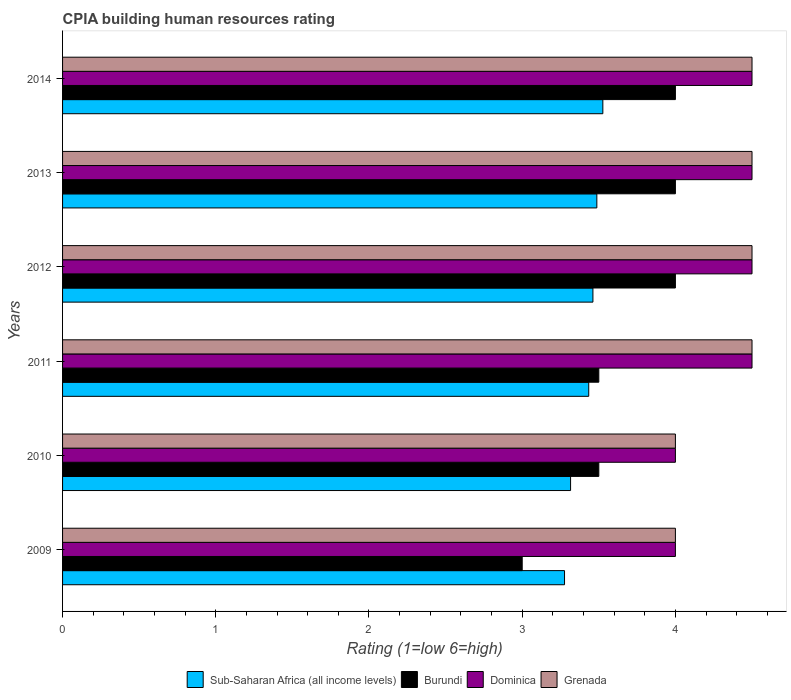How many different coloured bars are there?
Keep it short and to the point. 4. How many groups of bars are there?
Provide a short and direct response. 6. Are the number of bars on each tick of the Y-axis equal?
Give a very brief answer. Yes. How many bars are there on the 1st tick from the top?
Your answer should be compact. 4. How many bars are there on the 6th tick from the bottom?
Your answer should be very brief. 4. Across all years, what is the maximum CPIA rating in Sub-Saharan Africa (all income levels)?
Provide a succinct answer. 3.53. What is the total CPIA rating in Sub-Saharan Africa (all income levels) in the graph?
Offer a very short reply. 20.5. What is the difference between the CPIA rating in Sub-Saharan Africa (all income levels) in 2010 and that in 2013?
Provide a succinct answer. -0.17. What is the difference between the CPIA rating in Sub-Saharan Africa (all income levels) in 2010 and the CPIA rating in Dominica in 2011?
Ensure brevity in your answer.  -1.18. What is the average CPIA rating in Dominica per year?
Provide a short and direct response. 4.33. In the year 2012, what is the difference between the CPIA rating in Dominica and CPIA rating in Sub-Saharan Africa (all income levels)?
Give a very brief answer. 1.04. What is the ratio of the CPIA rating in Dominica in 2009 to that in 2010?
Offer a terse response. 1. Is the CPIA rating in Burundi in 2011 less than that in 2013?
Your answer should be compact. Yes. What is the difference between the highest and the second highest CPIA rating in Sub-Saharan Africa (all income levels)?
Provide a succinct answer. 0.04. What is the difference between the highest and the lowest CPIA rating in Sub-Saharan Africa (all income levels)?
Ensure brevity in your answer.  0.25. In how many years, is the CPIA rating in Sub-Saharan Africa (all income levels) greater than the average CPIA rating in Sub-Saharan Africa (all income levels) taken over all years?
Offer a terse response. 4. What does the 4th bar from the top in 2012 represents?
Make the answer very short. Sub-Saharan Africa (all income levels). What does the 4th bar from the bottom in 2010 represents?
Provide a short and direct response. Grenada. Is it the case that in every year, the sum of the CPIA rating in Burundi and CPIA rating in Sub-Saharan Africa (all income levels) is greater than the CPIA rating in Dominica?
Provide a short and direct response. Yes. Does the graph contain grids?
Provide a succinct answer. No. Where does the legend appear in the graph?
Offer a very short reply. Bottom center. How many legend labels are there?
Your response must be concise. 4. What is the title of the graph?
Your answer should be very brief. CPIA building human resources rating. What is the label or title of the Y-axis?
Your response must be concise. Years. What is the Rating (1=low 6=high) in Sub-Saharan Africa (all income levels) in 2009?
Provide a short and direct response. 3.28. What is the Rating (1=low 6=high) of Burundi in 2009?
Ensure brevity in your answer.  3. What is the Rating (1=low 6=high) of Sub-Saharan Africa (all income levels) in 2010?
Provide a succinct answer. 3.32. What is the Rating (1=low 6=high) of Burundi in 2010?
Your answer should be very brief. 3.5. What is the Rating (1=low 6=high) of Sub-Saharan Africa (all income levels) in 2011?
Ensure brevity in your answer.  3.43. What is the Rating (1=low 6=high) in Burundi in 2011?
Your answer should be compact. 3.5. What is the Rating (1=low 6=high) in Dominica in 2011?
Offer a very short reply. 4.5. What is the Rating (1=low 6=high) of Grenada in 2011?
Your response must be concise. 4.5. What is the Rating (1=low 6=high) in Sub-Saharan Africa (all income levels) in 2012?
Your response must be concise. 3.46. What is the Rating (1=low 6=high) of Sub-Saharan Africa (all income levels) in 2013?
Provide a succinct answer. 3.49. What is the Rating (1=low 6=high) of Burundi in 2013?
Make the answer very short. 4. What is the Rating (1=low 6=high) in Grenada in 2013?
Provide a succinct answer. 4.5. What is the Rating (1=low 6=high) in Sub-Saharan Africa (all income levels) in 2014?
Make the answer very short. 3.53. What is the Rating (1=low 6=high) of Dominica in 2014?
Offer a very short reply. 4.5. Across all years, what is the maximum Rating (1=low 6=high) of Sub-Saharan Africa (all income levels)?
Your response must be concise. 3.53. Across all years, what is the maximum Rating (1=low 6=high) of Burundi?
Ensure brevity in your answer.  4. Across all years, what is the maximum Rating (1=low 6=high) of Dominica?
Give a very brief answer. 4.5. Across all years, what is the minimum Rating (1=low 6=high) of Sub-Saharan Africa (all income levels)?
Offer a very short reply. 3.28. What is the total Rating (1=low 6=high) in Sub-Saharan Africa (all income levels) in the graph?
Provide a short and direct response. 20.5. What is the total Rating (1=low 6=high) of Dominica in the graph?
Your response must be concise. 26. What is the difference between the Rating (1=low 6=high) of Sub-Saharan Africa (all income levels) in 2009 and that in 2010?
Offer a very short reply. -0.04. What is the difference between the Rating (1=low 6=high) in Burundi in 2009 and that in 2010?
Provide a short and direct response. -0.5. What is the difference between the Rating (1=low 6=high) in Dominica in 2009 and that in 2010?
Give a very brief answer. 0. What is the difference between the Rating (1=low 6=high) of Grenada in 2009 and that in 2010?
Provide a succinct answer. 0. What is the difference between the Rating (1=low 6=high) of Sub-Saharan Africa (all income levels) in 2009 and that in 2011?
Ensure brevity in your answer.  -0.16. What is the difference between the Rating (1=low 6=high) of Burundi in 2009 and that in 2011?
Offer a terse response. -0.5. What is the difference between the Rating (1=low 6=high) of Dominica in 2009 and that in 2011?
Keep it short and to the point. -0.5. What is the difference between the Rating (1=low 6=high) in Sub-Saharan Africa (all income levels) in 2009 and that in 2012?
Your response must be concise. -0.19. What is the difference between the Rating (1=low 6=high) of Burundi in 2009 and that in 2012?
Keep it short and to the point. -1. What is the difference between the Rating (1=low 6=high) in Dominica in 2009 and that in 2012?
Your response must be concise. -0.5. What is the difference between the Rating (1=low 6=high) in Sub-Saharan Africa (all income levels) in 2009 and that in 2013?
Your response must be concise. -0.21. What is the difference between the Rating (1=low 6=high) of Burundi in 2009 and that in 2013?
Keep it short and to the point. -1. What is the difference between the Rating (1=low 6=high) in Dominica in 2009 and that in 2013?
Make the answer very short. -0.5. What is the difference between the Rating (1=low 6=high) in Sub-Saharan Africa (all income levels) in 2009 and that in 2014?
Your answer should be compact. -0.25. What is the difference between the Rating (1=low 6=high) in Grenada in 2009 and that in 2014?
Your answer should be compact. -0.5. What is the difference between the Rating (1=low 6=high) of Sub-Saharan Africa (all income levels) in 2010 and that in 2011?
Provide a short and direct response. -0.12. What is the difference between the Rating (1=low 6=high) in Burundi in 2010 and that in 2011?
Your answer should be compact. 0. What is the difference between the Rating (1=low 6=high) of Grenada in 2010 and that in 2011?
Give a very brief answer. -0.5. What is the difference between the Rating (1=low 6=high) in Sub-Saharan Africa (all income levels) in 2010 and that in 2012?
Provide a short and direct response. -0.15. What is the difference between the Rating (1=low 6=high) of Burundi in 2010 and that in 2012?
Your answer should be compact. -0.5. What is the difference between the Rating (1=low 6=high) of Sub-Saharan Africa (all income levels) in 2010 and that in 2013?
Keep it short and to the point. -0.17. What is the difference between the Rating (1=low 6=high) of Dominica in 2010 and that in 2013?
Your response must be concise. -0.5. What is the difference between the Rating (1=low 6=high) of Grenada in 2010 and that in 2013?
Offer a terse response. -0.5. What is the difference between the Rating (1=low 6=high) of Sub-Saharan Africa (all income levels) in 2010 and that in 2014?
Your answer should be compact. -0.21. What is the difference between the Rating (1=low 6=high) of Dominica in 2010 and that in 2014?
Provide a succinct answer. -0.5. What is the difference between the Rating (1=low 6=high) of Grenada in 2010 and that in 2014?
Give a very brief answer. -0.5. What is the difference between the Rating (1=low 6=high) of Sub-Saharan Africa (all income levels) in 2011 and that in 2012?
Your answer should be very brief. -0.03. What is the difference between the Rating (1=low 6=high) in Dominica in 2011 and that in 2012?
Make the answer very short. 0. What is the difference between the Rating (1=low 6=high) of Grenada in 2011 and that in 2012?
Provide a short and direct response. 0. What is the difference between the Rating (1=low 6=high) of Sub-Saharan Africa (all income levels) in 2011 and that in 2013?
Offer a terse response. -0.05. What is the difference between the Rating (1=low 6=high) of Sub-Saharan Africa (all income levels) in 2011 and that in 2014?
Keep it short and to the point. -0.09. What is the difference between the Rating (1=low 6=high) in Burundi in 2011 and that in 2014?
Make the answer very short. -0.5. What is the difference between the Rating (1=low 6=high) in Dominica in 2011 and that in 2014?
Give a very brief answer. 0. What is the difference between the Rating (1=low 6=high) of Grenada in 2011 and that in 2014?
Your response must be concise. 0. What is the difference between the Rating (1=low 6=high) of Sub-Saharan Africa (all income levels) in 2012 and that in 2013?
Give a very brief answer. -0.03. What is the difference between the Rating (1=low 6=high) of Dominica in 2012 and that in 2013?
Offer a terse response. 0. What is the difference between the Rating (1=low 6=high) in Sub-Saharan Africa (all income levels) in 2012 and that in 2014?
Your answer should be compact. -0.06. What is the difference between the Rating (1=low 6=high) of Burundi in 2012 and that in 2014?
Your answer should be compact. 0. What is the difference between the Rating (1=low 6=high) of Dominica in 2012 and that in 2014?
Offer a very short reply. 0. What is the difference between the Rating (1=low 6=high) in Grenada in 2012 and that in 2014?
Offer a very short reply. 0. What is the difference between the Rating (1=low 6=high) of Sub-Saharan Africa (all income levels) in 2013 and that in 2014?
Provide a short and direct response. -0.04. What is the difference between the Rating (1=low 6=high) in Grenada in 2013 and that in 2014?
Provide a succinct answer. 0. What is the difference between the Rating (1=low 6=high) of Sub-Saharan Africa (all income levels) in 2009 and the Rating (1=low 6=high) of Burundi in 2010?
Ensure brevity in your answer.  -0.22. What is the difference between the Rating (1=low 6=high) of Sub-Saharan Africa (all income levels) in 2009 and the Rating (1=low 6=high) of Dominica in 2010?
Provide a succinct answer. -0.72. What is the difference between the Rating (1=low 6=high) in Sub-Saharan Africa (all income levels) in 2009 and the Rating (1=low 6=high) in Grenada in 2010?
Offer a terse response. -0.72. What is the difference between the Rating (1=low 6=high) in Burundi in 2009 and the Rating (1=low 6=high) in Dominica in 2010?
Offer a terse response. -1. What is the difference between the Rating (1=low 6=high) in Burundi in 2009 and the Rating (1=low 6=high) in Grenada in 2010?
Your answer should be very brief. -1. What is the difference between the Rating (1=low 6=high) in Sub-Saharan Africa (all income levels) in 2009 and the Rating (1=low 6=high) in Burundi in 2011?
Your answer should be very brief. -0.22. What is the difference between the Rating (1=low 6=high) of Sub-Saharan Africa (all income levels) in 2009 and the Rating (1=low 6=high) of Dominica in 2011?
Provide a short and direct response. -1.22. What is the difference between the Rating (1=low 6=high) of Sub-Saharan Africa (all income levels) in 2009 and the Rating (1=low 6=high) of Grenada in 2011?
Ensure brevity in your answer.  -1.22. What is the difference between the Rating (1=low 6=high) in Burundi in 2009 and the Rating (1=low 6=high) in Dominica in 2011?
Your answer should be compact. -1.5. What is the difference between the Rating (1=low 6=high) in Dominica in 2009 and the Rating (1=low 6=high) in Grenada in 2011?
Keep it short and to the point. -0.5. What is the difference between the Rating (1=low 6=high) of Sub-Saharan Africa (all income levels) in 2009 and the Rating (1=low 6=high) of Burundi in 2012?
Your answer should be very brief. -0.72. What is the difference between the Rating (1=low 6=high) of Sub-Saharan Africa (all income levels) in 2009 and the Rating (1=low 6=high) of Dominica in 2012?
Your response must be concise. -1.22. What is the difference between the Rating (1=low 6=high) of Sub-Saharan Africa (all income levels) in 2009 and the Rating (1=low 6=high) of Grenada in 2012?
Keep it short and to the point. -1.22. What is the difference between the Rating (1=low 6=high) of Burundi in 2009 and the Rating (1=low 6=high) of Dominica in 2012?
Ensure brevity in your answer.  -1.5. What is the difference between the Rating (1=low 6=high) of Sub-Saharan Africa (all income levels) in 2009 and the Rating (1=low 6=high) of Burundi in 2013?
Offer a terse response. -0.72. What is the difference between the Rating (1=low 6=high) of Sub-Saharan Africa (all income levels) in 2009 and the Rating (1=low 6=high) of Dominica in 2013?
Offer a terse response. -1.22. What is the difference between the Rating (1=low 6=high) in Sub-Saharan Africa (all income levels) in 2009 and the Rating (1=low 6=high) in Grenada in 2013?
Offer a terse response. -1.22. What is the difference between the Rating (1=low 6=high) in Burundi in 2009 and the Rating (1=low 6=high) in Grenada in 2013?
Offer a very short reply. -1.5. What is the difference between the Rating (1=low 6=high) in Dominica in 2009 and the Rating (1=low 6=high) in Grenada in 2013?
Your response must be concise. -0.5. What is the difference between the Rating (1=low 6=high) in Sub-Saharan Africa (all income levels) in 2009 and the Rating (1=low 6=high) in Burundi in 2014?
Your answer should be very brief. -0.72. What is the difference between the Rating (1=low 6=high) of Sub-Saharan Africa (all income levels) in 2009 and the Rating (1=low 6=high) of Dominica in 2014?
Provide a succinct answer. -1.22. What is the difference between the Rating (1=low 6=high) in Sub-Saharan Africa (all income levels) in 2009 and the Rating (1=low 6=high) in Grenada in 2014?
Offer a very short reply. -1.22. What is the difference between the Rating (1=low 6=high) of Burundi in 2009 and the Rating (1=low 6=high) of Grenada in 2014?
Offer a very short reply. -1.5. What is the difference between the Rating (1=low 6=high) in Sub-Saharan Africa (all income levels) in 2010 and the Rating (1=low 6=high) in Burundi in 2011?
Ensure brevity in your answer.  -0.18. What is the difference between the Rating (1=low 6=high) in Sub-Saharan Africa (all income levels) in 2010 and the Rating (1=low 6=high) in Dominica in 2011?
Ensure brevity in your answer.  -1.18. What is the difference between the Rating (1=low 6=high) in Sub-Saharan Africa (all income levels) in 2010 and the Rating (1=low 6=high) in Grenada in 2011?
Provide a succinct answer. -1.18. What is the difference between the Rating (1=low 6=high) in Sub-Saharan Africa (all income levels) in 2010 and the Rating (1=low 6=high) in Burundi in 2012?
Ensure brevity in your answer.  -0.68. What is the difference between the Rating (1=low 6=high) in Sub-Saharan Africa (all income levels) in 2010 and the Rating (1=low 6=high) in Dominica in 2012?
Your answer should be very brief. -1.18. What is the difference between the Rating (1=low 6=high) of Sub-Saharan Africa (all income levels) in 2010 and the Rating (1=low 6=high) of Grenada in 2012?
Keep it short and to the point. -1.18. What is the difference between the Rating (1=low 6=high) in Dominica in 2010 and the Rating (1=low 6=high) in Grenada in 2012?
Provide a short and direct response. -0.5. What is the difference between the Rating (1=low 6=high) in Sub-Saharan Africa (all income levels) in 2010 and the Rating (1=low 6=high) in Burundi in 2013?
Offer a very short reply. -0.68. What is the difference between the Rating (1=low 6=high) of Sub-Saharan Africa (all income levels) in 2010 and the Rating (1=low 6=high) of Dominica in 2013?
Keep it short and to the point. -1.18. What is the difference between the Rating (1=low 6=high) in Sub-Saharan Africa (all income levels) in 2010 and the Rating (1=low 6=high) in Grenada in 2013?
Make the answer very short. -1.18. What is the difference between the Rating (1=low 6=high) in Burundi in 2010 and the Rating (1=low 6=high) in Dominica in 2013?
Ensure brevity in your answer.  -1. What is the difference between the Rating (1=low 6=high) of Burundi in 2010 and the Rating (1=low 6=high) of Grenada in 2013?
Keep it short and to the point. -1. What is the difference between the Rating (1=low 6=high) in Dominica in 2010 and the Rating (1=low 6=high) in Grenada in 2013?
Keep it short and to the point. -0.5. What is the difference between the Rating (1=low 6=high) of Sub-Saharan Africa (all income levels) in 2010 and the Rating (1=low 6=high) of Burundi in 2014?
Provide a succinct answer. -0.68. What is the difference between the Rating (1=low 6=high) of Sub-Saharan Africa (all income levels) in 2010 and the Rating (1=low 6=high) of Dominica in 2014?
Provide a short and direct response. -1.18. What is the difference between the Rating (1=low 6=high) of Sub-Saharan Africa (all income levels) in 2010 and the Rating (1=low 6=high) of Grenada in 2014?
Give a very brief answer. -1.18. What is the difference between the Rating (1=low 6=high) of Burundi in 2010 and the Rating (1=low 6=high) of Dominica in 2014?
Offer a terse response. -1. What is the difference between the Rating (1=low 6=high) in Dominica in 2010 and the Rating (1=low 6=high) in Grenada in 2014?
Make the answer very short. -0.5. What is the difference between the Rating (1=low 6=high) in Sub-Saharan Africa (all income levels) in 2011 and the Rating (1=low 6=high) in Burundi in 2012?
Offer a terse response. -0.57. What is the difference between the Rating (1=low 6=high) in Sub-Saharan Africa (all income levels) in 2011 and the Rating (1=low 6=high) in Dominica in 2012?
Ensure brevity in your answer.  -1.07. What is the difference between the Rating (1=low 6=high) of Sub-Saharan Africa (all income levels) in 2011 and the Rating (1=low 6=high) of Grenada in 2012?
Ensure brevity in your answer.  -1.07. What is the difference between the Rating (1=low 6=high) in Burundi in 2011 and the Rating (1=low 6=high) in Dominica in 2012?
Provide a succinct answer. -1. What is the difference between the Rating (1=low 6=high) in Burundi in 2011 and the Rating (1=low 6=high) in Grenada in 2012?
Your answer should be very brief. -1. What is the difference between the Rating (1=low 6=high) in Dominica in 2011 and the Rating (1=low 6=high) in Grenada in 2012?
Provide a short and direct response. 0. What is the difference between the Rating (1=low 6=high) in Sub-Saharan Africa (all income levels) in 2011 and the Rating (1=low 6=high) in Burundi in 2013?
Offer a very short reply. -0.57. What is the difference between the Rating (1=low 6=high) in Sub-Saharan Africa (all income levels) in 2011 and the Rating (1=low 6=high) in Dominica in 2013?
Provide a short and direct response. -1.07. What is the difference between the Rating (1=low 6=high) in Sub-Saharan Africa (all income levels) in 2011 and the Rating (1=low 6=high) in Grenada in 2013?
Provide a short and direct response. -1.07. What is the difference between the Rating (1=low 6=high) of Dominica in 2011 and the Rating (1=low 6=high) of Grenada in 2013?
Provide a short and direct response. 0. What is the difference between the Rating (1=low 6=high) of Sub-Saharan Africa (all income levels) in 2011 and the Rating (1=low 6=high) of Burundi in 2014?
Ensure brevity in your answer.  -0.57. What is the difference between the Rating (1=low 6=high) in Sub-Saharan Africa (all income levels) in 2011 and the Rating (1=low 6=high) in Dominica in 2014?
Your answer should be very brief. -1.07. What is the difference between the Rating (1=low 6=high) in Sub-Saharan Africa (all income levels) in 2011 and the Rating (1=low 6=high) in Grenada in 2014?
Your response must be concise. -1.07. What is the difference between the Rating (1=low 6=high) in Dominica in 2011 and the Rating (1=low 6=high) in Grenada in 2014?
Make the answer very short. 0. What is the difference between the Rating (1=low 6=high) in Sub-Saharan Africa (all income levels) in 2012 and the Rating (1=low 6=high) in Burundi in 2013?
Your answer should be very brief. -0.54. What is the difference between the Rating (1=low 6=high) in Sub-Saharan Africa (all income levels) in 2012 and the Rating (1=low 6=high) in Dominica in 2013?
Make the answer very short. -1.04. What is the difference between the Rating (1=low 6=high) in Sub-Saharan Africa (all income levels) in 2012 and the Rating (1=low 6=high) in Grenada in 2013?
Your response must be concise. -1.04. What is the difference between the Rating (1=low 6=high) of Burundi in 2012 and the Rating (1=low 6=high) of Grenada in 2013?
Make the answer very short. -0.5. What is the difference between the Rating (1=low 6=high) of Sub-Saharan Africa (all income levels) in 2012 and the Rating (1=low 6=high) of Burundi in 2014?
Provide a succinct answer. -0.54. What is the difference between the Rating (1=low 6=high) of Sub-Saharan Africa (all income levels) in 2012 and the Rating (1=low 6=high) of Dominica in 2014?
Make the answer very short. -1.04. What is the difference between the Rating (1=low 6=high) of Sub-Saharan Africa (all income levels) in 2012 and the Rating (1=low 6=high) of Grenada in 2014?
Offer a terse response. -1.04. What is the difference between the Rating (1=low 6=high) of Dominica in 2012 and the Rating (1=low 6=high) of Grenada in 2014?
Offer a terse response. 0. What is the difference between the Rating (1=low 6=high) of Sub-Saharan Africa (all income levels) in 2013 and the Rating (1=low 6=high) of Burundi in 2014?
Your response must be concise. -0.51. What is the difference between the Rating (1=low 6=high) of Sub-Saharan Africa (all income levels) in 2013 and the Rating (1=low 6=high) of Dominica in 2014?
Make the answer very short. -1.01. What is the difference between the Rating (1=low 6=high) in Sub-Saharan Africa (all income levels) in 2013 and the Rating (1=low 6=high) in Grenada in 2014?
Your response must be concise. -1.01. What is the difference between the Rating (1=low 6=high) of Dominica in 2013 and the Rating (1=low 6=high) of Grenada in 2014?
Keep it short and to the point. 0. What is the average Rating (1=low 6=high) of Sub-Saharan Africa (all income levels) per year?
Provide a succinct answer. 3.42. What is the average Rating (1=low 6=high) in Burundi per year?
Give a very brief answer. 3.67. What is the average Rating (1=low 6=high) of Dominica per year?
Make the answer very short. 4.33. What is the average Rating (1=low 6=high) in Grenada per year?
Give a very brief answer. 4.33. In the year 2009, what is the difference between the Rating (1=low 6=high) in Sub-Saharan Africa (all income levels) and Rating (1=low 6=high) in Burundi?
Keep it short and to the point. 0.28. In the year 2009, what is the difference between the Rating (1=low 6=high) in Sub-Saharan Africa (all income levels) and Rating (1=low 6=high) in Dominica?
Your answer should be compact. -0.72. In the year 2009, what is the difference between the Rating (1=low 6=high) of Sub-Saharan Africa (all income levels) and Rating (1=low 6=high) of Grenada?
Give a very brief answer. -0.72. In the year 2009, what is the difference between the Rating (1=low 6=high) of Burundi and Rating (1=low 6=high) of Dominica?
Your response must be concise. -1. In the year 2009, what is the difference between the Rating (1=low 6=high) of Burundi and Rating (1=low 6=high) of Grenada?
Provide a succinct answer. -1. In the year 2010, what is the difference between the Rating (1=low 6=high) in Sub-Saharan Africa (all income levels) and Rating (1=low 6=high) in Burundi?
Provide a succinct answer. -0.18. In the year 2010, what is the difference between the Rating (1=low 6=high) in Sub-Saharan Africa (all income levels) and Rating (1=low 6=high) in Dominica?
Your response must be concise. -0.68. In the year 2010, what is the difference between the Rating (1=low 6=high) of Sub-Saharan Africa (all income levels) and Rating (1=low 6=high) of Grenada?
Offer a very short reply. -0.68. In the year 2010, what is the difference between the Rating (1=low 6=high) in Burundi and Rating (1=low 6=high) in Dominica?
Your answer should be compact. -0.5. In the year 2010, what is the difference between the Rating (1=low 6=high) of Burundi and Rating (1=low 6=high) of Grenada?
Offer a terse response. -0.5. In the year 2011, what is the difference between the Rating (1=low 6=high) in Sub-Saharan Africa (all income levels) and Rating (1=low 6=high) in Burundi?
Give a very brief answer. -0.07. In the year 2011, what is the difference between the Rating (1=low 6=high) of Sub-Saharan Africa (all income levels) and Rating (1=low 6=high) of Dominica?
Provide a succinct answer. -1.07. In the year 2011, what is the difference between the Rating (1=low 6=high) in Sub-Saharan Africa (all income levels) and Rating (1=low 6=high) in Grenada?
Provide a succinct answer. -1.07. In the year 2011, what is the difference between the Rating (1=low 6=high) in Dominica and Rating (1=low 6=high) in Grenada?
Your answer should be compact. 0. In the year 2012, what is the difference between the Rating (1=low 6=high) of Sub-Saharan Africa (all income levels) and Rating (1=low 6=high) of Burundi?
Provide a succinct answer. -0.54. In the year 2012, what is the difference between the Rating (1=low 6=high) of Sub-Saharan Africa (all income levels) and Rating (1=low 6=high) of Dominica?
Offer a terse response. -1.04. In the year 2012, what is the difference between the Rating (1=low 6=high) in Sub-Saharan Africa (all income levels) and Rating (1=low 6=high) in Grenada?
Offer a terse response. -1.04. In the year 2012, what is the difference between the Rating (1=low 6=high) of Burundi and Rating (1=low 6=high) of Dominica?
Provide a succinct answer. -0.5. In the year 2013, what is the difference between the Rating (1=low 6=high) in Sub-Saharan Africa (all income levels) and Rating (1=low 6=high) in Burundi?
Keep it short and to the point. -0.51. In the year 2013, what is the difference between the Rating (1=low 6=high) in Sub-Saharan Africa (all income levels) and Rating (1=low 6=high) in Dominica?
Provide a succinct answer. -1.01. In the year 2013, what is the difference between the Rating (1=low 6=high) in Sub-Saharan Africa (all income levels) and Rating (1=low 6=high) in Grenada?
Keep it short and to the point. -1.01. In the year 2014, what is the difference between the Rating (1=low 6=high) in Sub-Saharan Africa (all income levels) and Rating (1=low 6=high) in Burundi?
Make the answer very short. -0.47. In the year 2014, what is the difference between the Rating (1=low 6=high) in Sub-Saharan Africa (all income levels) and Rating (1=low 6=high) in Dominica?
Ensure brevity in your answer.  -0.97. In the year 2014, what is the difference between the Rating (1=low 6=high) of Sub-Saharan Africa (all income levels) and Rating (1=low 6=high) of Grenada?
Your answer should be compact. -0.97. In the year 2014, what is the difference between the Rating (1=low 6=high) of Burundi and Rating (1=low 6=high) of Dominica?
Your response must be concise. -0.5. What is the ratio of the Rating (1=low 6=high) in Sub-Saharan Africa (all income levels) in 2009 to that in 2011?
Offer a terse response. 0.95. What is the ratio of the Rating (1=low 6=high) of Dominica in 2009 to that in 2011?
Provide a succinct answer. 0.89. What is the ratio of the Rating (1=low 6=high) in Grenada in 2009 to that in 2011?
Provide a short and direct response. 0.89. What is the ratio of the Rating (1=low 6=high) in Sub-Saharan Africa (all income levels) in 2009 to that in 2012?
Provide a succinct answer. 0.95. What is the ratio of the Rating (1=low 6=high) of Burundi in 2009 to that in 2012?
Offer a terse response. 0.75. What is the ratio of the Rating (1=low 6=high) in Grenada in 2009 to that in 2012?
Your answer should be very brief. 0.89. What is the ratio of the Rating (1=low 6=high) of Sub-Saharan Africa (all income levels) in 2009 to that in 2013?
Offer a terse response. 0.94. What is the ratio of the Rating (1=low 6=high) in Grenada in 2009 to that in 2013?
Make the answer very short. 0.89. What is the ratio of the Rating (1=low 6=high) of Sub-Saharan Africa (all income levels) in 2009 to that in 2014?
Your answer should be very brief. 0.93. What is the ratio of the Rating (1=low 6=high) in Dominica in 2009 to that in 2014?
Give a very brief answer. 0.89. What is the ratio of the Rating (1=low 6=high) in Grenada in 2009 to that in 2014?
Keep it short and to the point. 0.89. What is the ratio of the Rating (1=low 6=high) in Sub-Saharan Africa (all income levels) in 2010 to that in 2011?
Provide a succinct answer. 0.97. What is the ratio of the Rating (1=low 6=high) in Burundi in 2010 to that in 2011?
Ensure brevity in your answer.  1. What is the ratio of the Rating (1=low 6=high) in Dominica in 2010 to that in 2011?
Provide a succinct answer. 0.89. What is the ratio of the Rating (1=low 6=high) of Grenada in 2010 to that in 2011?
Offer a terse response. 0.89. What is the ratio of the Rating (1=low 6=high) of Sub-Saharan Africa (all income levels) in 2010 to that in 2012?
Give a very brief answer. 0.96. What is the ratio of the Rating (1=low 6=high) of Dominica in 2010 to that in 2012?
Give a very brief answer. 0.89. What is the ratio of the Rating (1=low 6=high) of Sub-Saharan Africa (all income levels) in 2010 to that in 2013?
Provide a short and direct response. 0.95. What is the ratio of the Rating (1=low 6=high) of Dominica in 2010 to that in 2013?
Your response must be concise. 0.89. What is the ratio of the Rating (1=low 6=high) of Sub-Saharan Africa (all income levels) in 2010 to that in 2014?
Your response must be concise. 0.94. What is the ratio of the Rating (1=low 6=high) in Burundi in 2010 to that in 2014?
Make the answer very short. 0.88. What is the ratio of the Rating (1=low 6=high) in Dominica in 2010 to that in 2014?
Offer a terse response. 0.89. What is the ratio of the Rating (1=low 6=high) of Sub-Saharan Africa (all income levels) in 2011 to that in 2012?
Your answer should be compact. 0.99. What is the ratio of the Rating (1=low 6=high) of Burundi in 2011 to that in 2012?
Provide a short and direct response. 0.88. What is the ratio of the Rating (1=low 6=high) in Dominica in 2011 to that in 2012?
Offer a terse response. 1. What is the ratio of the Rating (1=low 6=high) in Sub-Saharan Africa (all income levels) in 2011 to that in 2013?
Provide a succinct answer. 0.98. What is the ratio of the Rating (1=low 6=high) in Burundi in 2011 to that in 2013?
Provide a succinct answer. 0.88. What is the ratio of the Rating (1=low 6=high) of Dominica in 2011 to that in 2013?
Provide a succinct answer. 1. What is the ratio of the Rating (1=low 6=high) of Sub-Saharan Africa (all income levels) in 2011 to that in 2014?
Offer a terse response. 0.97. What is the ratio of the Rating (1=low 6=high) in Dominica in 2012 to that in 2013?
Ensure brevity in your answer.  1. What is the ratio of the Rating (1=low 6=high) of Sub-Saharan Africa (all income levels) in 2012 to that in 2014?
Offer a very short reply. 0.98. What is the ratio of the Rating (1=low 6=high) in Dominica in 2012 to that in 2014?
Provide a short and direct response. 1. What is the ratio of the Rating (1=low 6=high) in Sub-Saharan Africa (all income levels) in 2013 to that in 2014?
Give a very brief answer. 0.99. What is the ratio of the Rating (1=low 6=high) of Dominica in 2013 to that in 2014?
Your answer should be compact. 1. What is the difference between the highest and the second highest Rating (1=low 6=high) of Sub-Saharan Africa (all income levels)?
Provide a short and direct response. 0.04. What is the difference between the highest and the second highest Rating (1=low 6=high) of Burundi?
Your answer should be compact. 0. What is the difference between the highest and the lowest Rating (1=low 6=high) in Dominica?
Your response must be concise. 0.5. What is the difference between the highest and the lowest Rating (1=low 6=high) of Grenada?
Give a very brief answer. 0.5. 